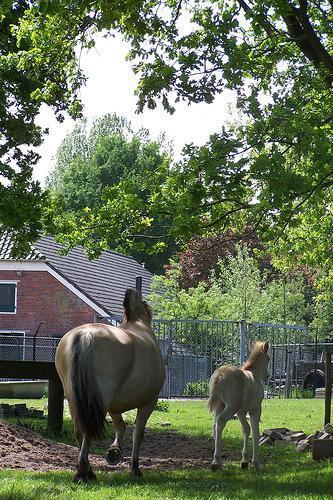How many buildings are in the picture?
Give a very brief answer. 1. 